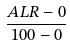Convert formula to latex. <formula><loc_0><loc_0><loc_500><loc_500>\frac { A L R - 0 } { 1 0 0 - 0 }</formula> 